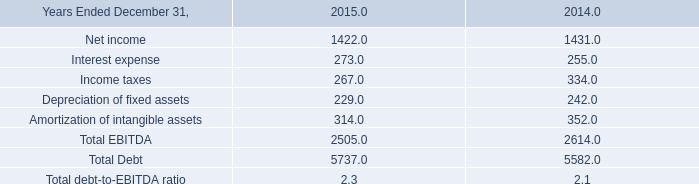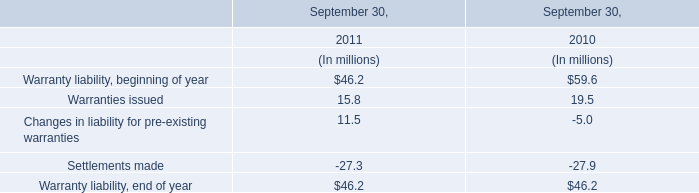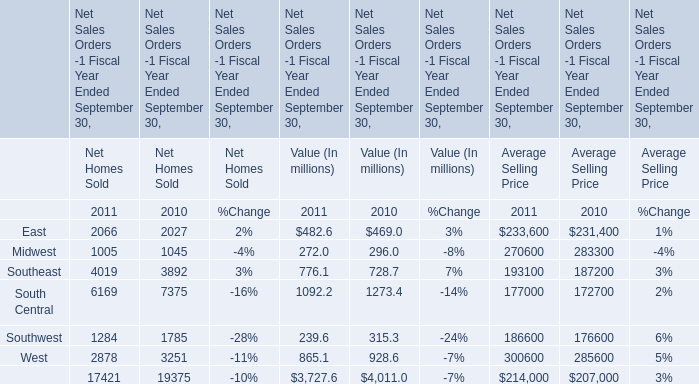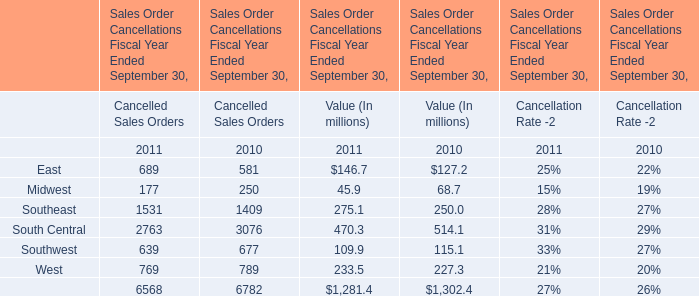Is the total amount of all elements in 2011 greater than that in 2010 for Cancelled Sales Orders? 
Answer: no. 